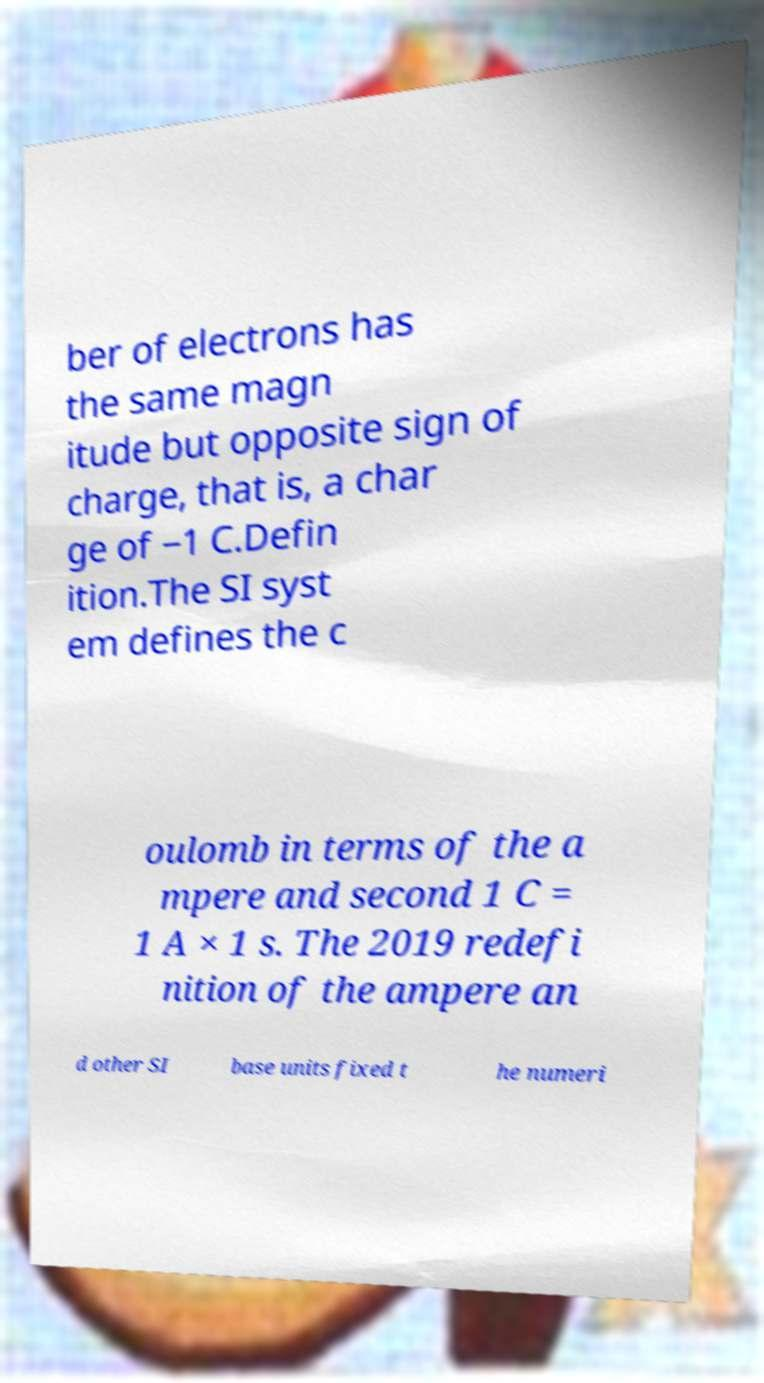Could you assist in decoding the text presented in this image and type it out clearly? ber of electrons has the same magn itude but opposite sign of charge, that is, a char ge of −1 C.Defin ition.The SI syst em defines the c oulomb in terms of the a mpere and second 1 C = 1 A × 1 s. The 2019 redefi nition of the ampere an d other SI base units fixed t he numeri 